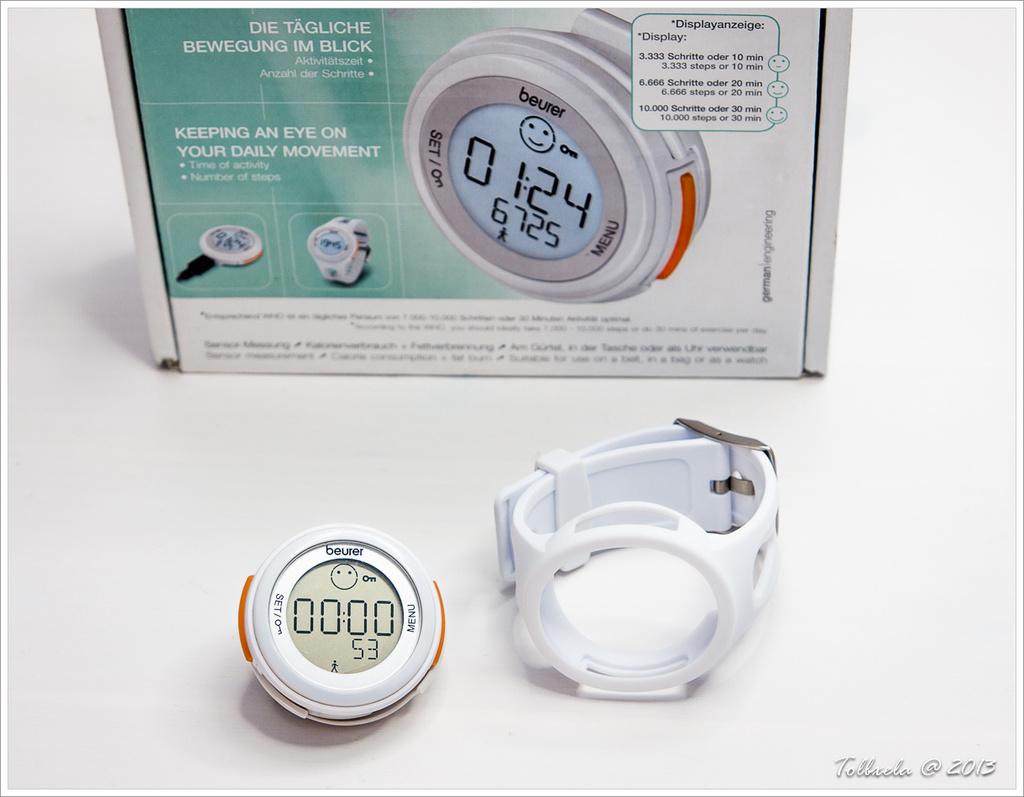What numbers are displayed on the picture on the box?
Provide a succinct answer. 01:24 6725. 